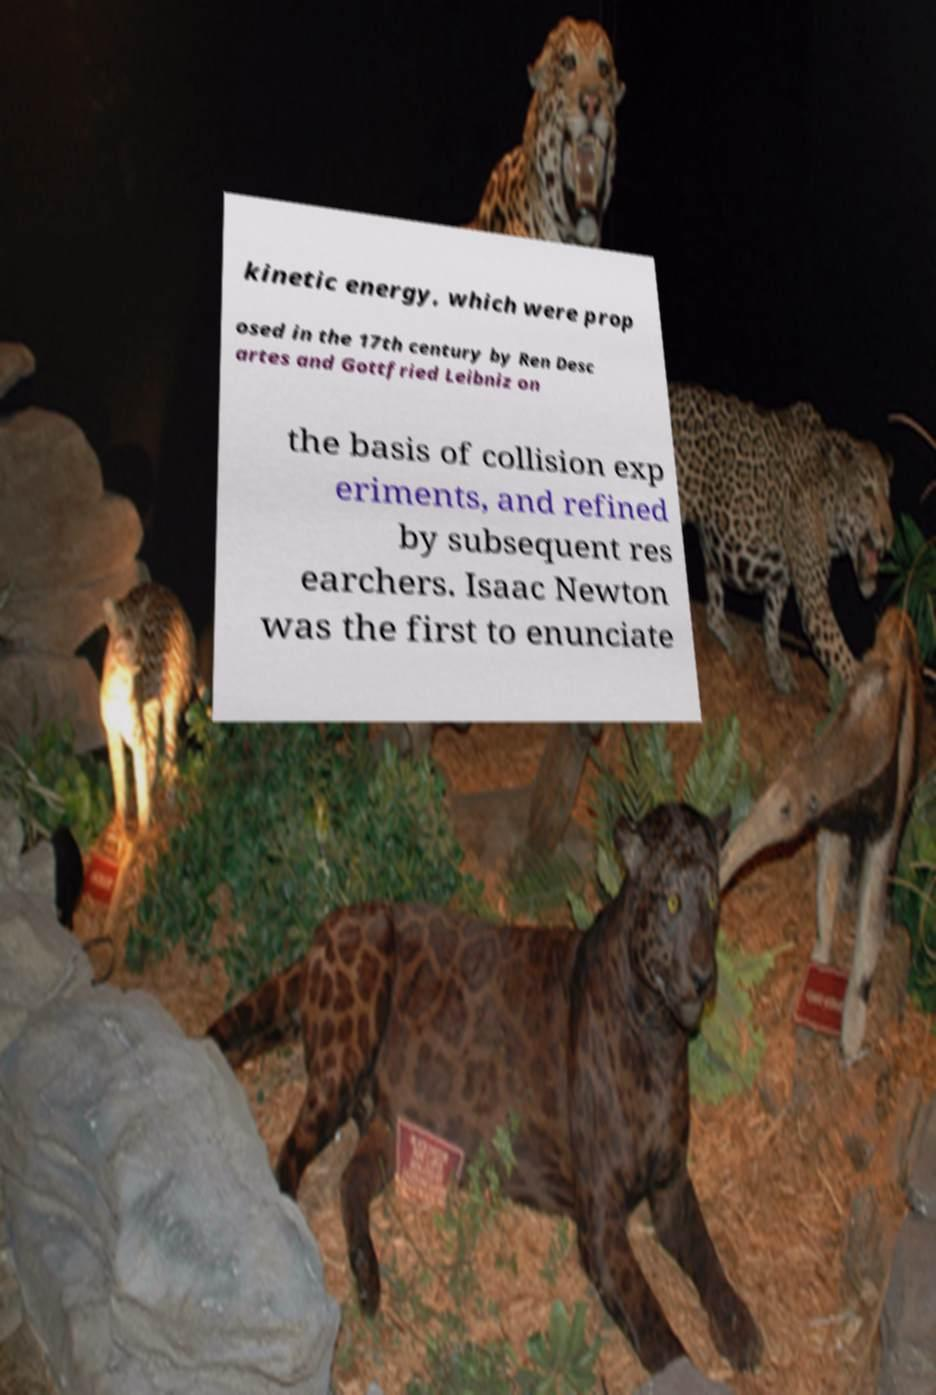There's text embedded in this image that I need extracted. Can you transcribe it verbatim? kinetic energy, which were prop osed in the 17th century by Ren Desc artes and Gottfried Leibniz on the basis of collision exp eriments, and refined by subsequent res earchers. Isaac Newton was the first to enunciate 